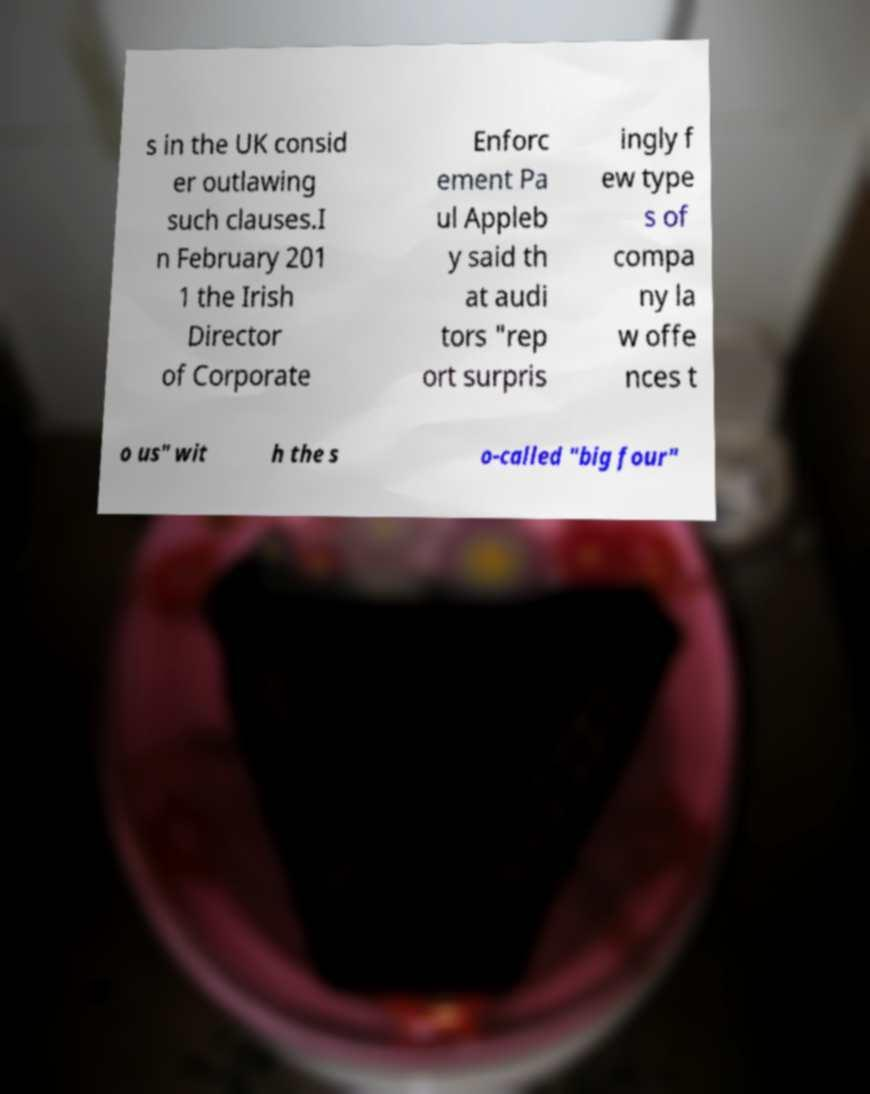Could you extract and type out the text from this image? s in the UK consid er outlawing such clauses.I n February 201 1 the Irish Director of Corporate Enforc ement Pa ul Appleb y said th at audi tors "rep ort surpris ingly f ew type s of compa ny la w offe nces t o us" wit h the s o-called "big four" 